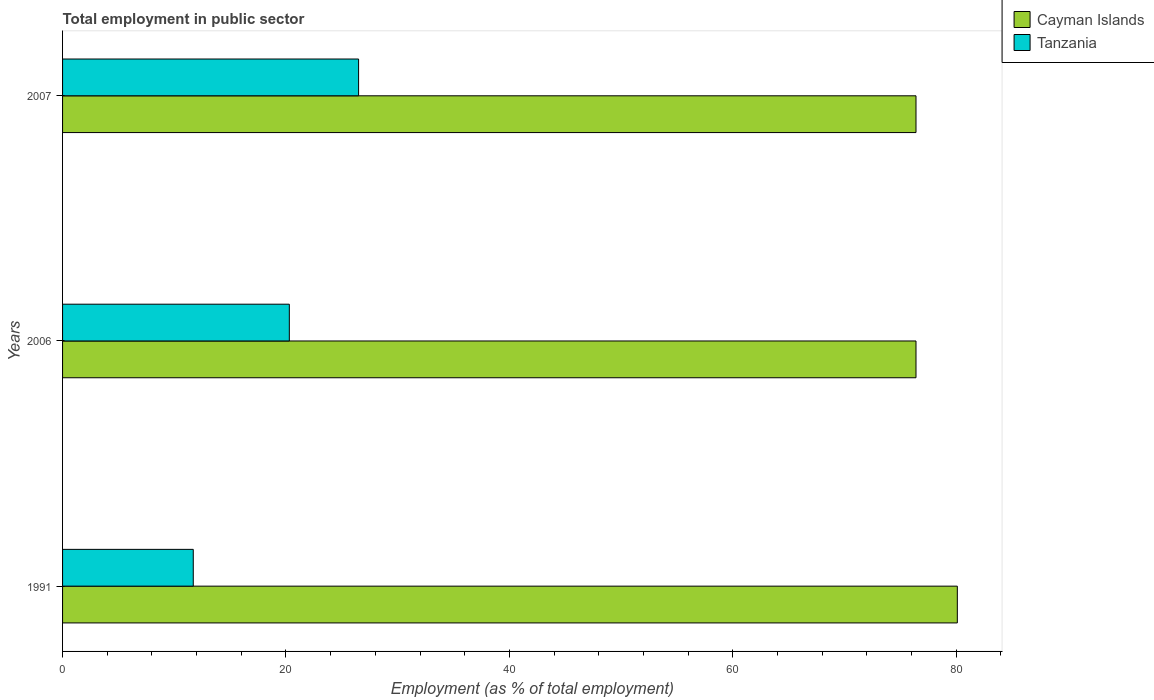How many different coloured bars are there?
Give a very brief answer. 2. Are the number of bars on each tick of the Y-axis equal?
Your answer should be compact. Yes. How many bars are there on the 2nd tick from the top?
Keep it short and to the point. 2. What is the label of the 3rd group of bars from the top?
Offer a very short reply. 1991. In how many cases, is the number of bars for a given year not equal to the number of legend labels?
Provide a succinct answer. 0. What is the employment in public sector in Tanzania in 2007?
Keep it short and to the point. 26.5. Across all years, what is the maximum employment in public sector in Tanzania?
Your answer should be very brief. 26.5. Across all years, what is the minimum employment in public sector in Tanzania?
Offer a very short reply. 11.7. In which year was the employment in public sector in Cayman Islands maximum?
Provide a short and direct response. 1991. In which year was the employment in public sector in Tanzania minimum?
Keep it short and to the point. 1991. What is the total employment in public sector in Tanzania in the graph?
Keep it short and to the point. 58.5. What is the difference between the employment in public sector in Cayman Islands in 1991 and that in 2007?
Your answer should be compact. 3.7. What is the difference between the employment in public sector in Cayman Islands in 2006 and the employment in public sector in Tanzania in 1991?
Offer a terse response. 64.7. What is the average employment in public sector in Cayman Islands per year?
Ensure brevity in your answer.  77.63. In the year 2006, what is the difference between the employment in public sector in Tanzania and employment in public sector in Cayman Islands?
Provide a short and direct response. -56.1. In how many years, is the employment in public sector in Cayman Islands greater than 20 %?
Make the answer very short. 3. What is the ratio of the employment in public sector in Cayman Islands in 2006 to that in 2007?
Your answer should be compact. 1. Is the employment in public sector in Tanzania in 1991 less than that in 2006?
Your answer should be compact. Yes. Is the difference between the employment in public sector in Tanzania in 1991 and 2006 greater than the difference between the employment in public sector in Cayman Islands in 1991 and 2006?
Your response must be concise. No. What is the difference between the highest and the second highest employment in public sector in Cayman Islands?
Provide a succinct answer. 3.7. What is the difference between the highest and the lowest employment in public sector in Tanzania?
Ensure brevity in your answer.  14.8. Is the sum of the employment in public sector in Cayman Islands in 2006 and 2007 greater than the maximum employment in public sector in Tanzania across all years?
Keep it short and to the point. Yes. What does the 2nd bar from the top in 2007 represents?
Offer a terse response. Cayman Islands. What does the 1st bar from the bottom in 2007 represents?
Offer a terse response. Cayman Islands. How many years are there in the graph?
Offer a very short reply. 3. Does the graph contain grids?
Your answer should be compact. No. Where does the legend appear in the graph?
Your answer should be compact. Top right. How many legend labels are there?
Your response must be concise. 2. What is the title of the graph?
Provide a short and direct response. Total employment in public sector. Does "Haiti" appear as one of the legend labels in the graph?
Offer a terse response. No. What is the label or title of the X-axis?
Keep it short and to the point. Employment (as % of total employment). What is the Employment (as % of total employment) of Cayman Islands in 1991?
Make the answer very short. 80.1. What is the Employment (as % of total employment) of Tanzania in 1991?
Your answer should be compact. 11.7. What is the Employment (as % of total employment) in Cayman Islands in 2006?
Provide a succinct answer. 76.4. What is the Employment (as % of total employment) in Tanzania in 2006?
Offer a terse response. 20.3. What is the Employment (as % of total employment) in Cayman Islands in 2007?
Offer a very short reply. 76.4. Across all years, what is the maximum Employment (as % of total employment) in Cayman Islands?
Offer a terse response. 80.1. Across all years, what is the minimum Employment (as % of total employment) of Cayman Islands?
Your response must be concise. 76.4. Across all years, what is the minimum Employment (as % of total employment) in Tanzania?
Provide a short and direct response. 11.7. What is the total Employment (as % of total employment) of Cayman Islands in the graph?
Give a very brief answer. 232.9. What is the total Employment (as % of total employment) in Tanzania in the graph?
Offer a terse response. 58.5. What is the difference between the Employment (as % of total employment) in Cayman Islands in 1991 and that in 2006?
Your response must be concise. 3.7. What is the difference between the Employment (as % of total employment) of Cayman Islands in 1991 and that in 2007?
Keep it short and to the point. 3.7. What is the difference between the Employment (as % of total employment) in Tanzania in 1991 and that in 2007?
Your response must be concise. -14.8. What is the difference between the Employment (as % of total employment) of Tanzania in 2006 and that in 2007?
Provide a succinct answer. -6.2. What is the difference between the Employment (as % of total employment) in Cayman Islands in 1991 and the Employment (as % of total employment) in Tanzania in 2006?
Give a very brief answer. 59.8. What is the difference between the Employment (as % of total employment) in Cayman Islands in 1991 and the Employment (as % of total employment) in Tanzania in 2007?
Offer a terse response. 53.6. What is the difference between the Employment (as % of total employment) of Cayman Islands in 2006 and the Employment (as % of total employment) of Tanzania in 2007?
Make the answer very short. 49.9. What is the average Employment (as % of total employment) in Cayman Islands per year?
Make the answer very short. 77.63. What is the average Employment (as % of total employment) of Tanzania per year?
Offer a very short reply. 19.5. In the year 1991, what is the difference between the Employment (as % of total employment) in Cayman Islands and Employment (as % of total employment) in Tanzania?
Your answer should be compact. 68.4. In the year 2006, what is the difference between the Employment (as % of total employment) of Cayman Islands and Employment (as % of total employment) of Tanzania?
Make the answer very short. 56.1. In the year 2007, what is the difference between the Employment (as % of total employment) in Cayman Islands and Employment (as % of total employment) in Tanzania?
Offer a terse response. 49.9. What is the ratio of the Employment (as % of total employment) of Cayman Islands in 1991 to that in 2006?
Provide a succinct answer. 1.05. What is the ratio of the Employment (as % of total employment) in Tanzania in 1991 to that in 2006?
Give a very brief answer. 0.58. What is the ratio of the Employment (as % of total employment) in Cayman Islands in 1991 to that in 2007?
Your response must be concise. 1.05. What is the ratio of the Employment (as % of total employment) of Tanzania in 1991 to that in 2007?
Your answer should be compact. 0.44. What is the ratio of the Employment (as % of total employment) of Tanzania in 2006 to that in 2007?
Provide a short and direct response. 0.77. What is the difference between the highest and the second highest Employment (as % of total employment) of Cayman Islands?
Keep it short and to the point. 3.7. What is the difference between the highest and the lowest Employment (as % of total employment) in Cayman Islands?
Offer a very short reply. 3.7. What is the difference between the highest and the lowest Employment (as % of total employment) of Tanzania?
Offer a terse response. 14.8. 